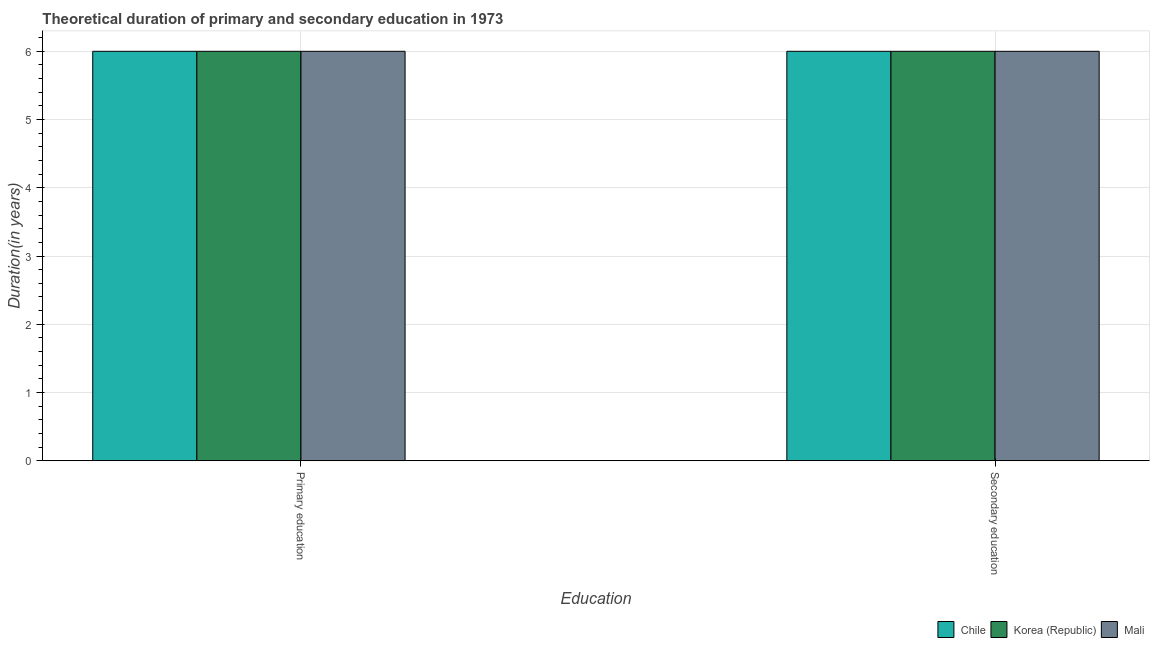Are the number of bars per tick equal to the number of legend labels?
Your response must be concise. Yes. Are the number of bars on each tick of the X-axis equal?
Provide a succinct answer. Yes. How many bars are there on the 2nd tick from the right?
Make the answer very short. 3. What is the label of the 2nd group of bars from the left?
Your answer should be very brief. Secondary education. What is the duration of primary education in Mali?
Your response must be concise. 6. Across all countries, what is the maximum duration of primary education?
Offer a terse response. 6. What is the total duration of primary education in the graph?
Offer a very short reply. 18. What is the difference between the duration of secondary education in Mali and that in Korea (Republic)?
Make the answer very short. 0. What is the difference between the duration of secondary education in Mali and the duration of primary education in Chile?
Keep it short and to the point. 0. What is the difference between the duration of primary education and duration of secondary education in Mali?
Your response must be concise. 0. What is the ratio of the duration of secondary education in Chile to that in Mali?
Your answer should be very brief. 1. Is the duration of primary education in Mali less than that in Korea (Republic)?
Offer a terse response. No. What does the 1st bar from the left in Primary education represents?
Provide a short and direct response. Chile. What does the 1st bar from the right in Primary education represents?
Give a very brief answer. Mali. How many countries are there in the graph?
Provide a short and direct response. 3. What is the difference between two consecutive major ticks on the Y-axis?
Provide a short and direct response. 1. Are the values on the major ticks of Y-axis written in scientific E-notation?
Provide a short and direct response. No. Does the graph contain any zero values?
Offer a terse response. No. Does the graph contain grids?
Provide a short and direct response. Yes. Where does the legend appear in the graph?
Ensure brevity in your answer.  Bottom right. How many legend labels are there?
Provide a short and direct response. 3. How are the legend labels stacked?
Your response must be concise. Horizontal. What is the title of the graph?
Your response must be concise. Theoretical duration of primary and secondary education in 1973. Does "Aruba" appear as one of the legend labels in the graph?
Keep it short and to the point. No. What is the label or title of the X-axis?
Keep it short and to the point. Education. What is the label or title of the Y-axis?
Provide a short and direct response. Duration(in years). What is the Duration(in years) of Korea (Republic) in Primary education?
Your answer should be compact. 6. What is the Duration(in years) in Chile in Secondary education?
Your answer should be very brief. 6. What is the Duration(in years) in Korea (Republic) in Secondary education?
Your answer should be compact. 6. Across all Education, what is the maximum Duration(in years) in Korea (Republic)?
Your answer should be compact. 6. Across all Education, what is the minimum Duration(in years) in Chile?
Give a very brief answer. 6. What is the total Duration(in years) of Mali in the graph?
Ensure brevity in your answer.  12. What is the difference between the Duration(in years) in Chile in Primary education and that in Secondary education?
Make the answer very short. 0. What is the difference between the Duration(in years) of Chile in Primary education and the Duration(in years) of Mali in Secondary education?
Make the answer very short. 0. What is the difference between the Duration(in years) in Korea (Republic) in Primary education and the Duration(in years) in Mali in Secondary education?
Offer a terse response. 0. What is the average Duration(in years) of Korea (Republic) per Education?
Your response must be concise. 6. What is the average Duration(in years) of Mali per Education?
Ensure brevity in your answer.  6. What is the difference between the Duration(in years) in Chile and Duration(in years) in Mali in Primary education?
Make the answer very short. 0. What is the difference between the Duration(in years) of Korea (Republic) and Duration(in years) of Mali in Primary education?
Give a very brief answer. 0. What is the difference between the Duration(in years) of Chile and Duration(in years) of Korea (Republic) in Secondary education?
Give a very brief answer. 0. What is the difference between the Duration(in years) in Chile and Duration(in years) in Mali in Secondary education?
Your response must be concise. 0. What is the difference between the Duration(in years) in Korea (Republic) and Duration(in years) in Mali in Secondary education?
Provide a short and direct response. 0. What is the ratio of the Duration(in years) in Chile in Primary education to that in Secondary education?
Your response must be concise. 1. What is the difference between the highest and the second highest Duration(in years) in Mali?
Your answer should be compact. 0. What is the difference between the highest and the lowest Duration(in years) of Chile?
Your answer should be very brief. 0. What is the difference between the highest and the lowest Duration(in years) in Mali?
Your answer should be very brief. 0. 